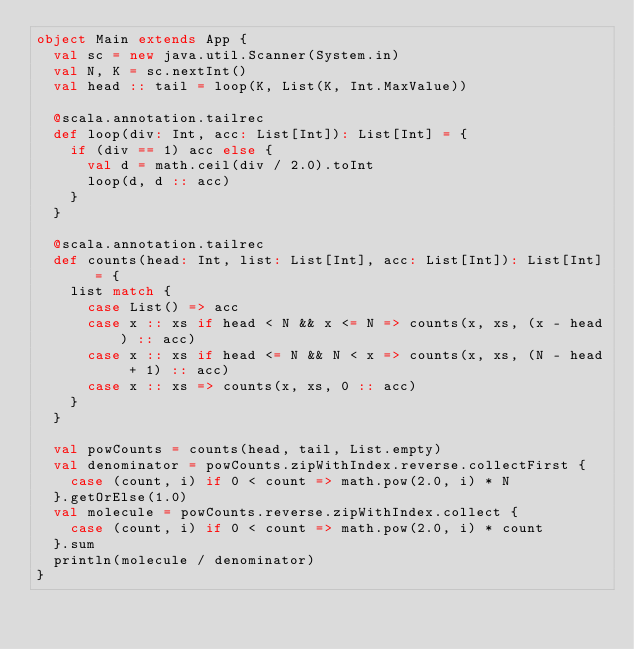<code> <loc_0><loc_0><loc_500><loc_500><_Scala_>object Main extends App {
  val sc = new java.util.Scanner(System.in)
  val N, K = sc.nextInt()
  val head :: tail = loop(K, List(K, Int.MaxValue))

  @scala.annotation.tailrec
  def loop(div: Int, acc: List[Int]): List[Int] = {
    if (div == 1) acc else {
      val d = math.ceil(div / 2.0).toInt
      loop(d, d :: acc)
    }
  }

  @scala.annotation.tailrec
  def counts(head: Int, list: List[Int], acc: List[Int]): List[Int] = {
    list match {
      case List() => acc
      case x :: xs if head < N && x <= N => counts(x, xs, (x - head) :: acc)
      case x :: xs if head <= N && N < x => counts(x, xs, (N - head + 1) :: acc)
      case x :: xs => counts(x, xs, 0 :: acc)
    }
  }

  val powCounts = counts(head, tail, List.empty)
  val denominator = powCounts.zipWithIndex.reverse.collectFirst {
    case (count, i) if 0 < count => math.pow(2.0, i) * N
  }.getOrElse(1.0)
  val molecule = powCounts.reverse.zipWithIndex.collect {
    case (count, i) if 0 < count => math.pow(2.0, i) * count
  }.sum
  println(molecule / denominator)
}
</code> 